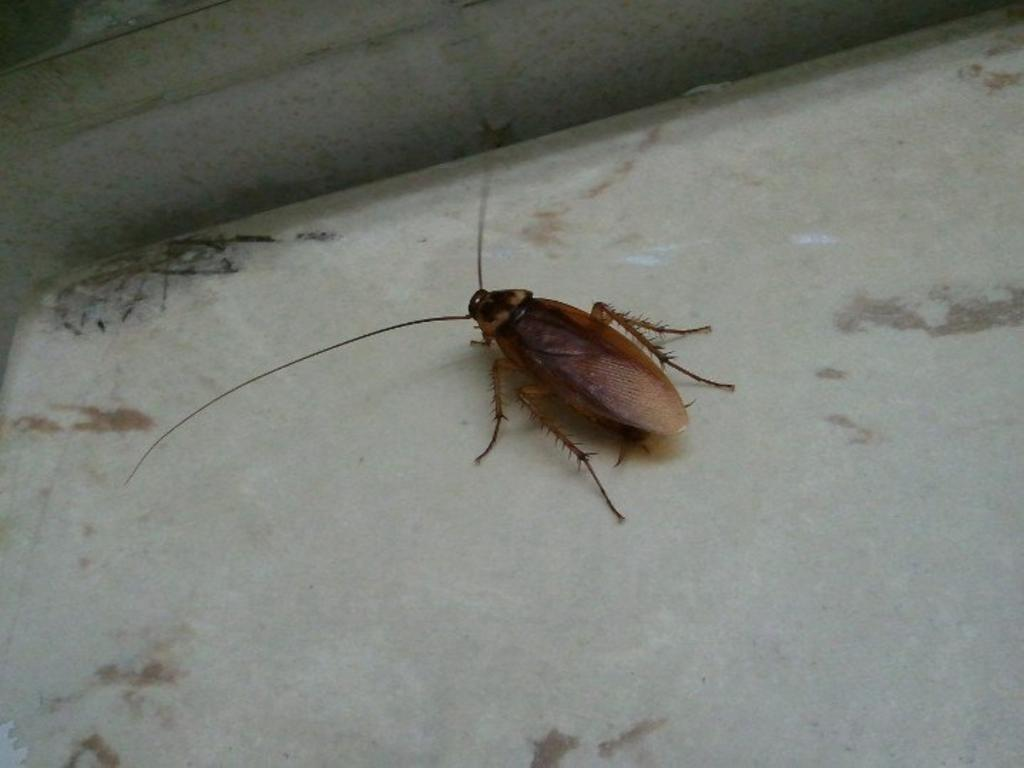What is the main subject of the image? There is a cockroach in the image. Where is the cockroach located? The cockroach is on the floor. How many oranges are being used in the volleyball game in the image? There is no volleyball game or oranges present in the image; it features a cockroach on the floor. 